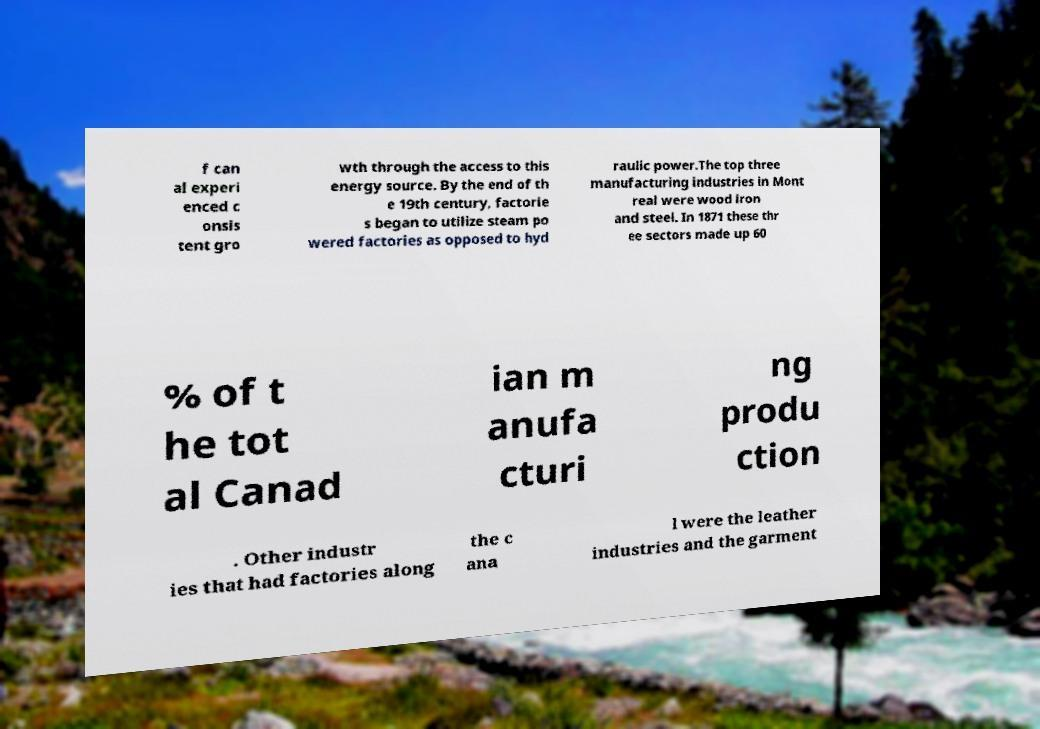Can you read and provide the text displayed in the image?This photo seems to have some interesting text. Can you extract and type it out for me? f can al experi enced c onsis tent gro wth through the access to this energy source. By the end of th e 19th century, factorie s began to utilize steam po wered factories as opposed to hyd raulic power.The top three manufacturing industries in Mont real were wood iron and steel. In 1871 these thr ee sectors made up 60 % of t he tot al Canad ian m anufa cturi ng produ ction . Other industr ies that had factories along the c ana l were the leather industries and the garment 